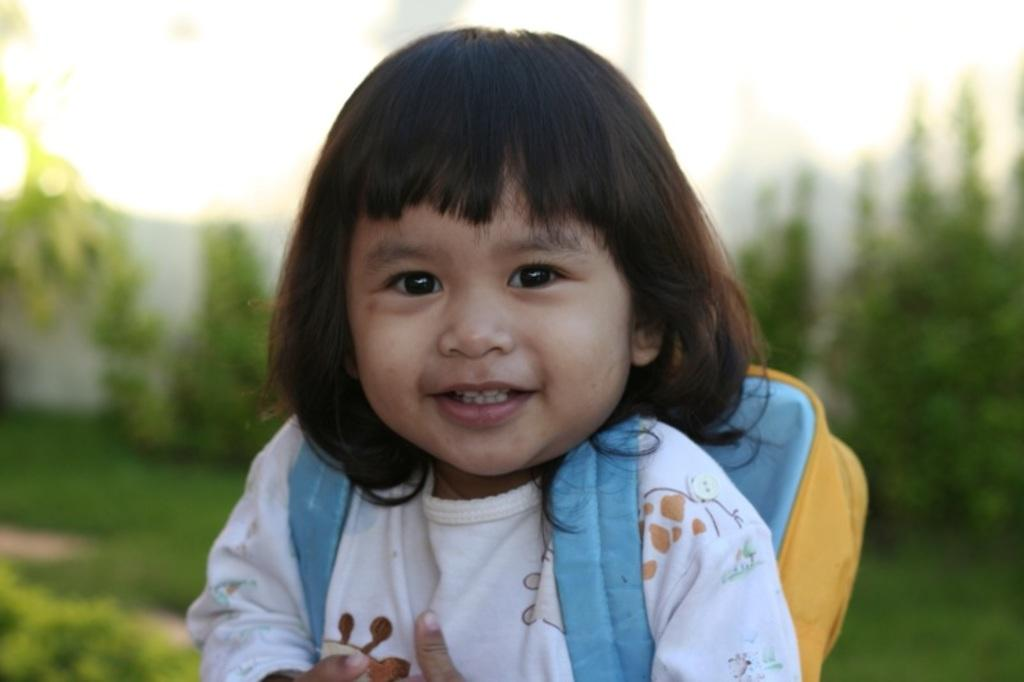What is the main subject of the image? The main subject of the image is a kid. What is the kid holding or carrying in the image? The kid is carrying a bag. Can you describe the background of the image? The background of the image is blurred. What scientific experiment is the kid conducting in the image? There is no indication in the image that the kid is conducting a scientific experiment. 